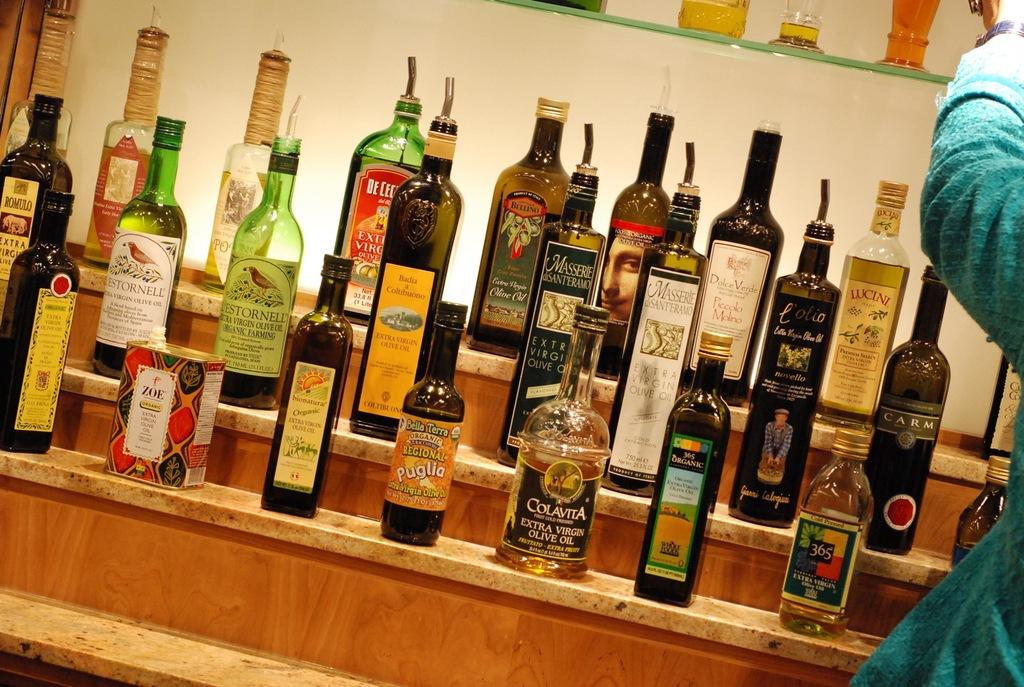<image>
Share a concise interpretation of the image provided. Different Brands of Extra Virgin Coconut Oil arranged on a Shelf 